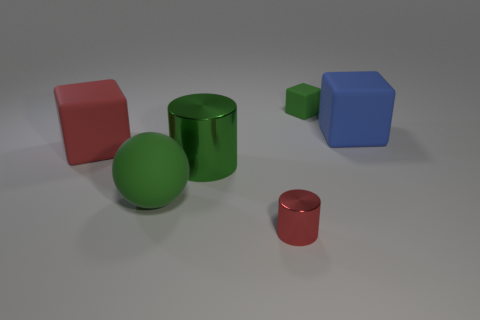There is a metallic cylinder that is the same color as the tiny rubber cube; what size is it?
Offer a very short reply. Large. How many cubes are both right of the tiny green cube and to the left of the red cylinder?
Make the answer very short. 0. The other small object that is the same shape as the green metallic thing is what color?
Offer a very short reply. Red. Is the number of large green things less than the number of tiny red matte cylinders?
Your answer should be very brief. No. Do the green matte sphere and the metal cylinder left of the tiny red metal cylinder have the same size?
Offer a terse response. Yes. What is the color of the big matte cube that is left of the red object that is in front of the big green metallic cylinder?
Ensure brevity in your answer.  Red. How many things are either large green objects behind the rubber ball or rubber things in front of the blue block?
Offer a terse response. 3. Do the blue matte thing and the red matte object have the same size?
Offer a very short reply. Yes. There is a green rubber thing to the right of the tiny red metal cylinder; is it the same shape as the big rubber thing that is in front of the big green metal object?
Your response must be concise. No. The blue thing is what size?
Offer a terse response. Large. 